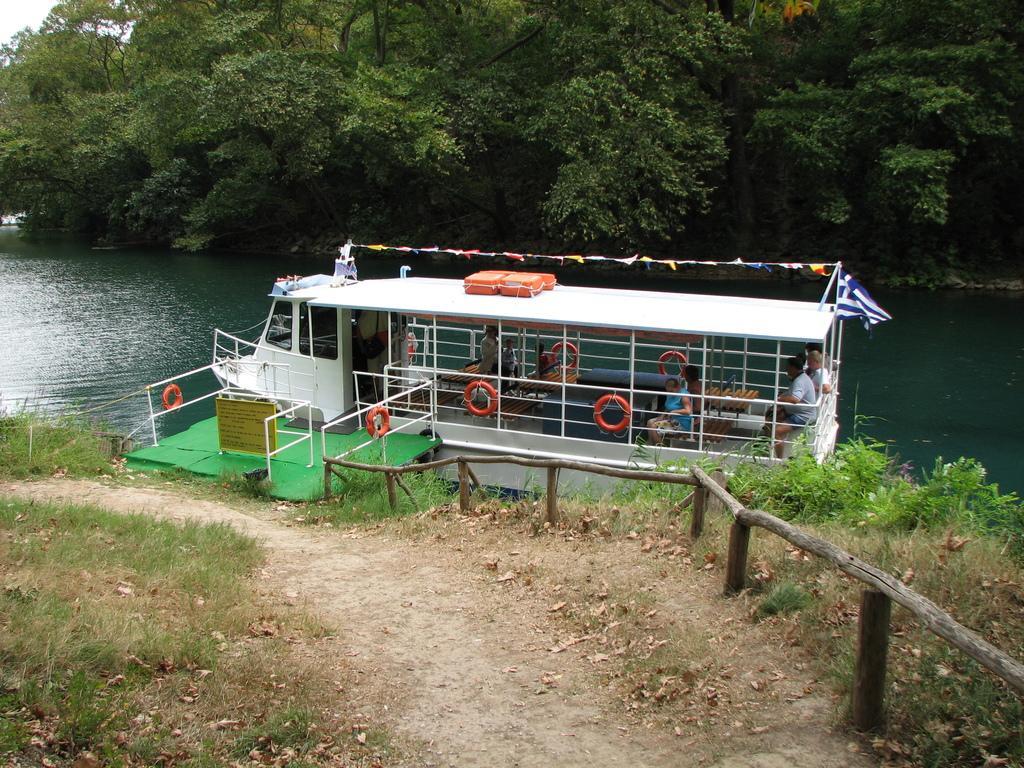Could you give a brief overview of what you see in this image? In the foreground of this image, there is a path to which on either side there is grass. On the right, there is a wooden railing and in the background, there is a boat on the water near a dock and also trees, water and the sky. 